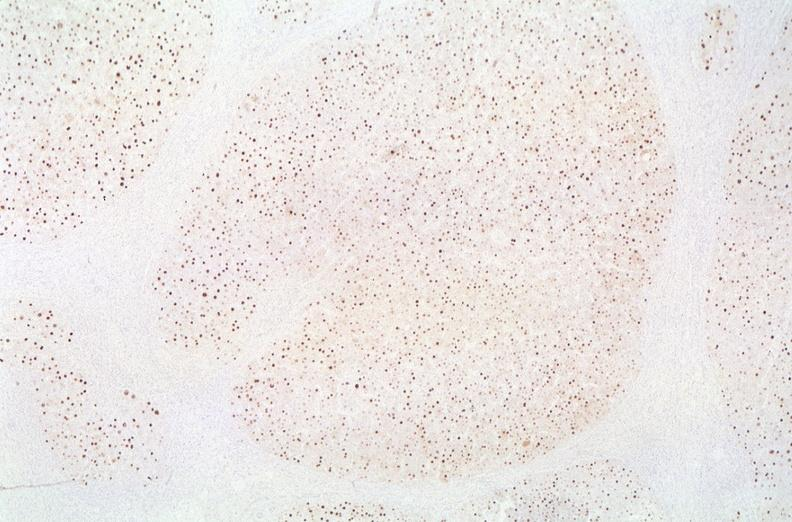s hepatobiliary present?
Answer the question using a single word or phrase. Yes 